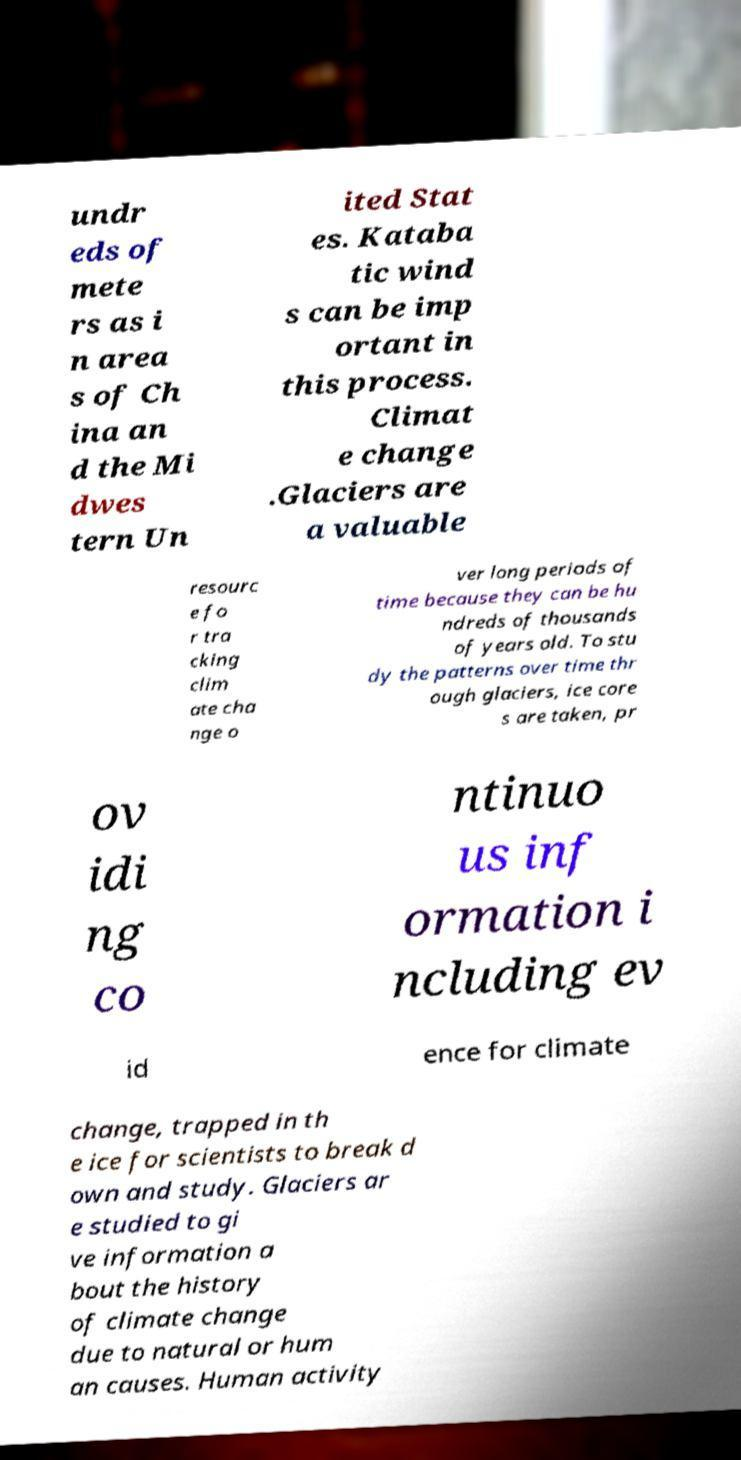Please identify and transcribe the text found in this image. undr eds of mete rs as i n area s of Ch ina an d the Mi dwes tern Un ited Stat es. Kataba tic wind s can be imp ortant in this process. Climat e change .Glaciers are a valuable resourc e fo r tra cking clim ate cha nge o ver long periods of time because they can be hu ndreds of thousands of years old. To stu dy the patterns over time thr ough glaciers, ice core s are taken, pr ov idi ng co ntinuo us inf ormation i ncluding ev id ence for climate change, trapped in th e ice for scientists to break d own and study. Glaciers ar e studied to gi ve information a bout the history of climate change due to natural or hum an causes. Human activity 